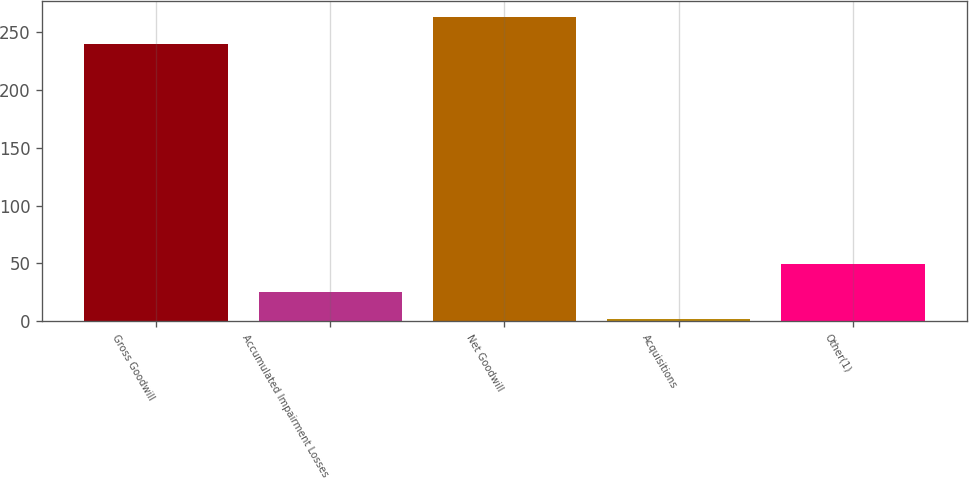Convert chart to OTSL. <chart><loc_0><loc_0><loc_500><loc_500><bar_chart><fcel>Gross Goodwill<fcel>Accumulated Impairment Losses<fcel>Net Goodwill<fcel>Acquisitions<fcel>Other(1)<nl><fcel>240<fcel>25.4<fcel>263.84<fcel>1.56<fcel>49.24<nl></chart> 